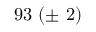Convert formula to latex. <formula><loc_0><loc_0><loc_500><loc_500>9 3 \ ( \pm \ 2 )</formula> 